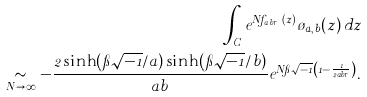<formula> <loc_0><loc_0><loc_500><loc_500>\int _ { C } e ^ { N f _ { a , b , r } ( z ) } \tau _ { a , b } ( z ) \, d z \\ \underset { N \to \infty } { \sim } - \frac { 2 \sinh ( \pi \sqrt { - 1 } / a ) \sinh ( \pi \sqrt { - 1 } / b ) } { a b } e ^ { N \pi \sqrt { - 1 } \left ( 1 - \frac { 1 } { 2 a b r } \right ) } .</formula> 